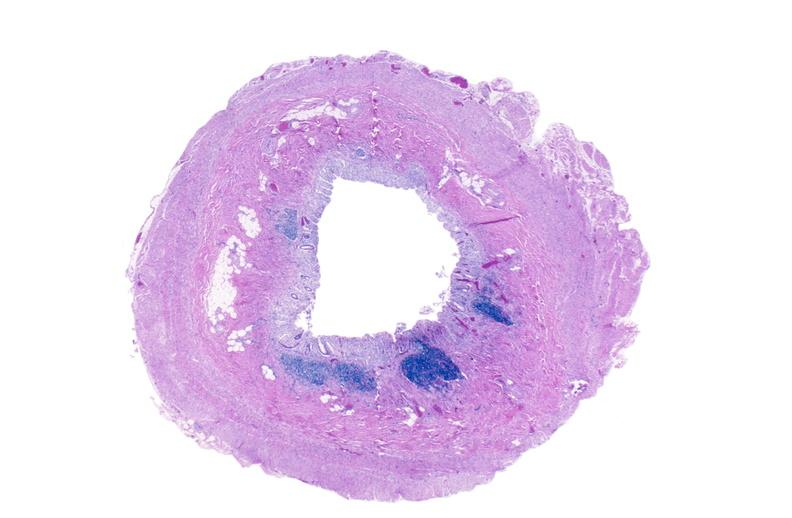does polyarteritis nodosa show normal appendix?
Answer the question using a single word or phrase. No 